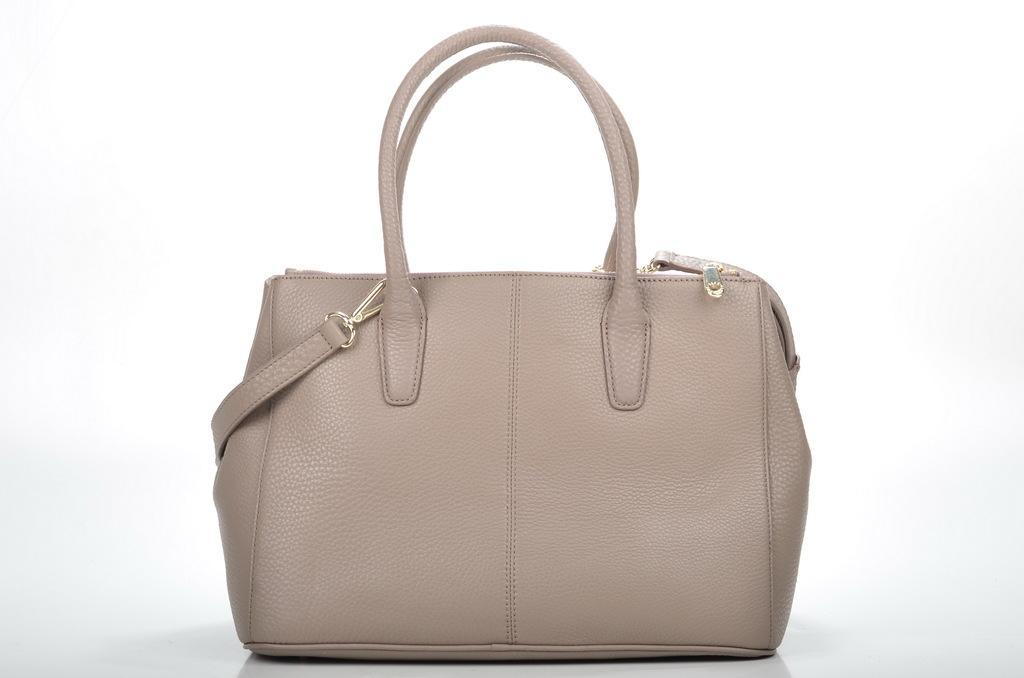Can you describe this image briefly? White color bag with belt and strap. 